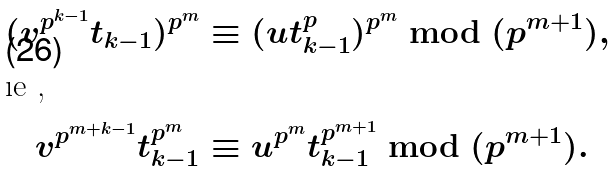<formula> <loc_0><loc_0><loc_500><loc_500>( v ^ { p ^ { k - 1 } } t _ { k - 1 } ) ^ { p ^ { m } } & \equiv ( u t _ { k - 1 } ^ { p } ) ^ { p ^ { m } } \bmod { ( p ^ { m + 1 } ) } , \\ \intertext { \i e , } v ^ { p ^ { m + k - 1 } } t _ { k - 1 } ^ { p ^ { m } } & \equiv u ^ { p ^ { m } } t _ { k - 1 } ^ { p ^ { m + 1 } } \bmod { ( p ^ { m + 1 } ) } .</formula> 